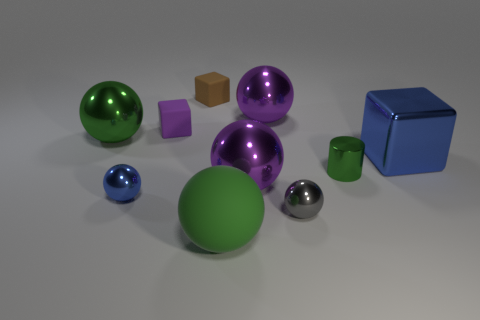Does the brown rubber thing have the same shape as the green rubber object?
Provide a succinct answer. No. What number of objects are either balls that are left of the brown matte object or purple matte blocks?
Give a very brief answer. 3. What size is the purple block that is made of the same material as the brown thing?
Your answer should be very brief. Small. How many large balls have the same color as the cylinder?
Provide a short and direct response. 2. What number of small objects are brown cubes or shiny cylinders?
Make the answer very short. 2. There is a metallic sphere that is the same color as the large cube; what size is it?
Your answer should be compact. Small. Is there a purple sphere that has the same material as the brown object?
Give a very brief answer. No. There is a big purple ball in front of the small green cylinder; what material is it?
Offer a terse response. Metal. Do the rubber thing in front of the large blue metal cube and the big sphere behind the big green metallic thing have the same color?
Make the answer very short. No. The rubber thing that is the same size as the shiny cube is what color?
Provide a short and direct response. Green. 